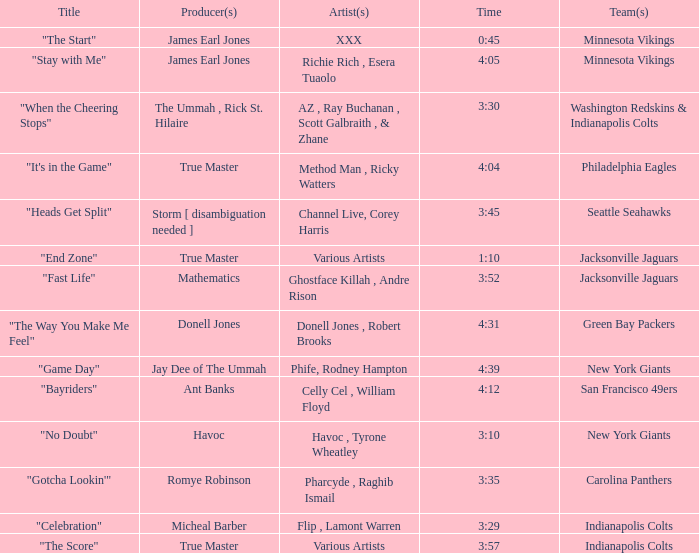Who is the musician behind the seattle seahawks track? Channel Live, Corey Harris. I'm looking to parse the entire table for insights. Could you assist me with that? {'header': ['Title', 'Producer(s)', 'Artist(s)', 'Time', 'Team(s)'], 'rows': [['"The Start"', 'James Earl Jones', 'XXX', '0:45', 'Minnesota Vikings'], ['"Stay with Me"', 'James Earl Jones', 'Richie Rich , Esera Tuaolo', '4:05', 'Minnesota Vikings'], ['"When the Cheering Stops"', 'The Ummah , Rick St. Hilaire', 'AZ , Ray Buchanan , Scott Galbraith , & Zhane', '3:30', 'Washington Redskins & Indianapolis Colts'], ['"It\'s in the Game"', 'True Master', 'Method Man , Ricky Watters', '4:04', 'Philadelphia Eagles'], ['"Heads Get Split"', 'Storm [ disambiguation needed ]', 'Channel Live, Corey Harris', '3:45', 'Seattle Seahawks'], ['"End Zone"', 'True Master', 'Various Artists', '1:10', 'Jacksonville Jaguars'], ['"Fast Life"', 'Mathematics', 'Ghostface Killah , Andre Rison', '3:52', 'Jacksonville Jaguars'], ['"The Way You Make Me Feel"', 'Donell Jones', 'Donell Jones , Robert Brooks', '4:31', 'Green Bay Packers'], ['"Game Day"', 'Jay Dee of The Ummah', 'Phife, Rodney Hampton', '4:39', 'New York Giants'], ['"Bayriders"', 'Ant Banks', 'Celly Cel , William Floyd', '4:12', 'San Francisco 49ers'], ['"No Doubt"', 'Havoc', 'Havoc , Tyrone Wheatley', '3:10', 'New York Giants'], ['"Gotcha Lookin\'"', 'Romye Robinson', 'Pharcyde , Raghib Ismail', '3:35', 'Carolina Panthers'], ['"Celebration"', 'Micheal Barber', 'Flip , Lamont Warren', '3:29', 'Indianapolis Colts'], ['"The Score"', 'True Master', 'Various Artists', '3:57', 'Indianapolis Colts']]} 